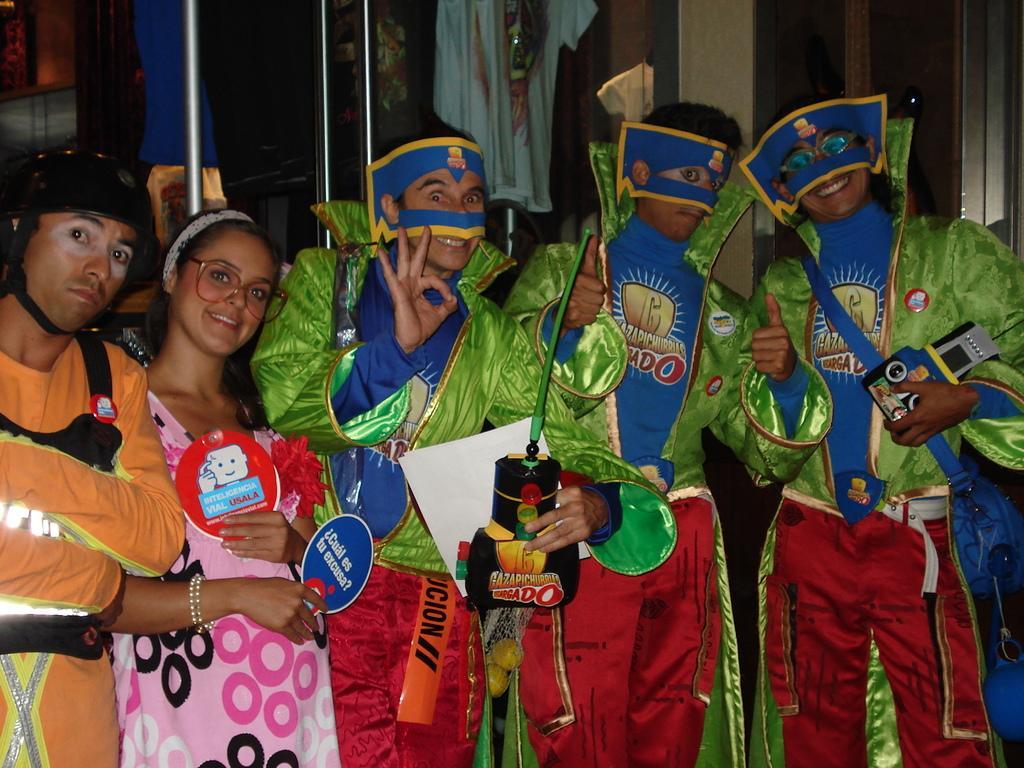Could you give a brief overview of what you see in this image? In this picture I can see 5 persons who are standing in front and all of them are wearing different color costumes and I see 3 of them are holding things in their hands and I see few of them are smiling. 